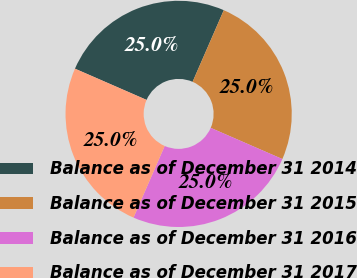Convert chart to OTSL. <chart><loc_0><loc_0><loc_500><loc_500><pie_chart><fcel>Balance as of December 31 2014<fcel>Balance as of December 31 2015<fcel>Balance as of December 31 2016<fcel>Balance as of December 31 2017<nl><fcel>24.99%<fcel>25.0%<fcel>25.0%<fcel>25.01%<nl></chart> 